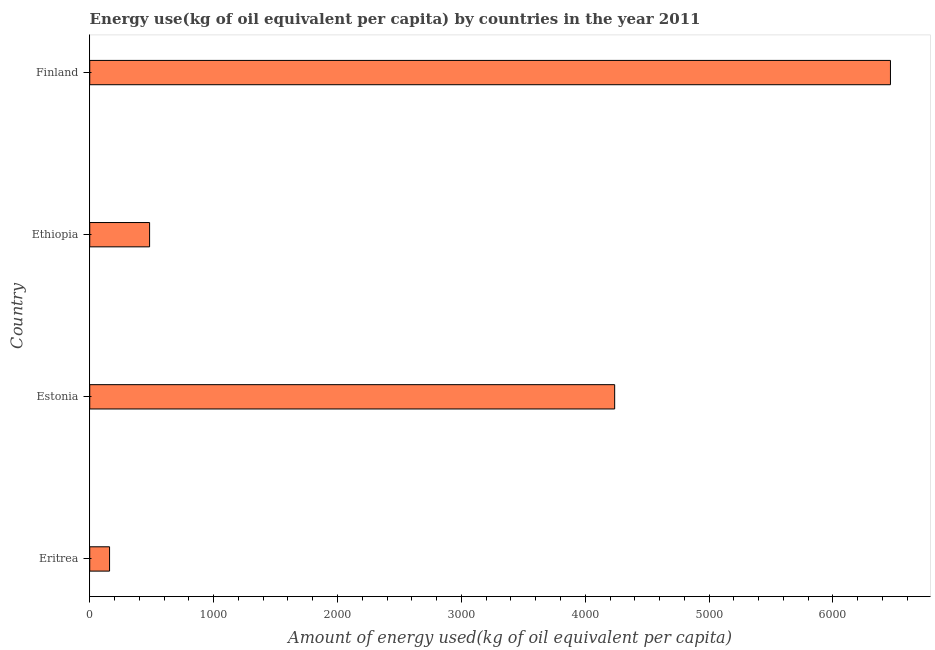Does the graph contain any zero values?
Provide a short and direct response. No. Does the graph contain grids?
Offer a very short reply. No. What is the title of the graph?
Keep it short and to the point. Energy use(kg of oil equivalent per capita) by countries in the year 2011. What is the label or title of the X-axis?
Give a very brief answer. Amount of energy used(kg of oil equivalent per capita). What is the label or title of the Y-axis?
Offer a very short reply. Country. What is the amount of energy used in Finland?
Give a very brief answer. 6463.99. Across all countries, what is the maximum amount of energy used?
Your answer should be compact. 6463.99. Across all countries, what is the minimum amount of energy used?
Your response must be concise. 160.07. In which country was the amount of energy used minimum?
Your answer should be very brief. Eritrea. What is the sum of the amount of energy used?
Make the answer very short. 1.13e+04. What is the difference between the amount of energy used in Ethiopia and Finland?
Your answer should be very brief. -5980.79. What is the average amount of energy used per country?
Keep it short and to the point. 2836.24. What is the median amount of energy used?
Make the answer very short. 2360.46. What is the ratio of the amount of energy used in Estonia to that in Finland?
Keep it short and to the point. 0.66. Is the difference between the amount of energy used in Estonia and Finland greater than the difference between any two countries?
Ensure brevity in your answer.  No. What is the difference between the highest and the second highest amount of energy used?
Provide a succinct answer. 2226.26. What is the difference between the highest and the lowest amount of energy used?
Keep it short and to the point. 6303.92. In how many countries, is the amount of energy used greater than the average amount of energy used taken over all countries?
Your answer should be very brief. 2. Are all the bars in the graph horizontal?
Your answer should be compact. Yes. What is the difference between two consecutive major ticks on the X-axis?
Provide a short and direct response. 1000. What is the Amount of energy used(kg of oil equivalent per capita) of Eritrea?
Offer a very short reply. 160.07. What is the Amount of energy used(kg of oil equivalent per capita) in Estonia?
Your response must be concise. 4237.73. What is the Amount of energy used(kg of oil equivalent per capita) in Ethiopia?
Your response must be concise. 483.19. What is the Amount of energy used(kg of oil equivalent per capita) in Finland?
Keep it short and to the point. 6463.99. What is the difference between the Amount of energy used(kg of oil equivalent per capita) in Eritrea and Estonia?
Your answer should be very brief. -4077.66. What is the difference between the Amount of energy used(kg of oil equivalent per capita) in Eritrea and Ethiopia?
Your answer should be compact. -323.13. What is the difference between the Amount of energy used(kg of oil equivalent per capita) in Eritrea and Finland?
Your answer should be very brief. -6303.92. What is the difference between the Amount of energy used(kg of oil equivalent per capita) in Estonia and Ethiopia?
Make the answer very short. 3754.53. What is the difference between the Amount of energy used(kg of oil equivalent per capita) in Estonia and Finland?
Offer a very short reply. -2226.26. What is the difference between the Amount of energy used(kg of oil equivalent per capita) in Ethiopia and Finland?
Give a very brief answer. -5980.79. What is the ratio of the Amount of energy used(kg of oil equivalent per capita) in Eritrea to that in Estonia?
Make the answer very short. 0.04. What is the ratio of the Amount of energy used(kg of oil equivalent per capita) in Eritrea to that in Ethiopia?
Make the answer very short. 0.33. What is the ratio of the Amount of energy used(kg of oil equivalent per capita) in Eritrea to that in Finland?
Your answer should be very brief. 0.03. What is the ratio of the Amount of energy used(kg of oil equivalent per capita) in Estonia to that in Ethiopia?
Keep it short and to the point. 8.77. What is the ratio of the Amount of energy used(kg of oil equivalent per capita) in Estonia to that in Finland?
Your answer should be compact. 0.66. What is the ratio of the Amount of energy used(kg of oil equivalent per capita) in Ethiopia to that in Finland?
Your answer should be compact. 0.07. 